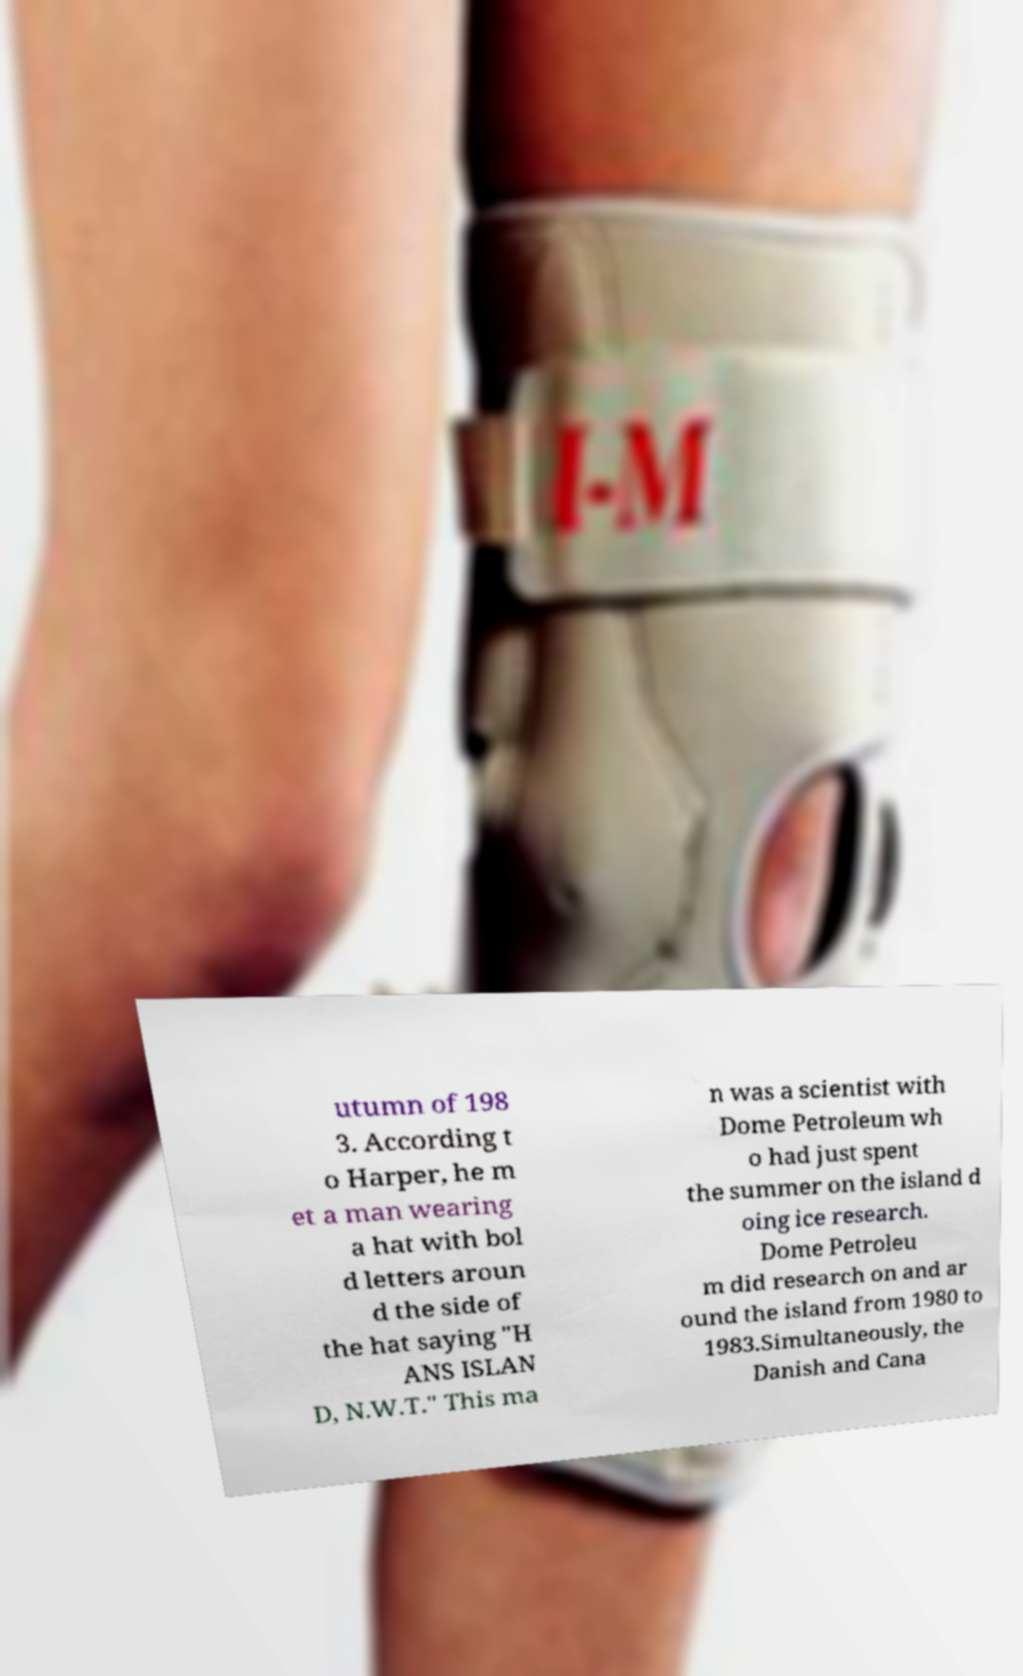For documentation purposes, I need the text within this image transcribed. Could you provide that? utumn of 198 3. According t o Harper, he m et a man wearing a hat with bol d letters aroun d the side of the hat saying "H ANS ISLAN D, N.W.T." This ma n was a scientist with Dome Petroleum wh o had just spent the summer on the island d oing ice research. Dome Petroleu m did research on and ar ound the island from 1980 to 1983.Simultaneously, the Danish and Cana 